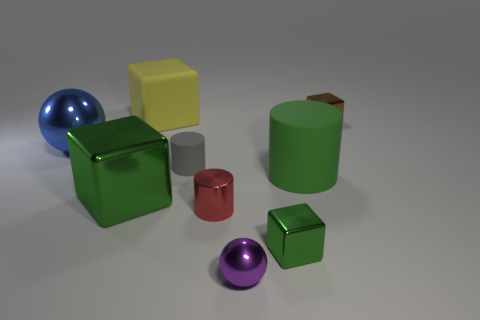Are there any large matte objects that have the same shape as the tiny gray object?
Ensure brevity in your answer.  Yes. What shape is the large matte thing that is behind the metal block that is right of the tiny green block?
Ensure brevity in your answer.  Cube. What number of cylinders are either large green metallic things or big matte objects?
Give a very brief answer. 1. There is a large object that is the same color as the large rubber cylinder; what is its material?
Offer a terse response. Metal. There is a large metal thing in front of the small gray cylinder; is its shape the same as the tiny metallic object on the left side of the purple thing?
Give a very brief answer. No. There is a cube that is both in front of the yellow matte thing and behind the large green matte cylinder; what is its color?
Offer a very short reply. Brown. Does the matte block have the same color as the large object that is right of the matte cube?
Ensure brevity in your answer.  No. What size is the block that is both in front of the blue metallic ball and on the left side of the tiny purple ball?
Your answer should be compact. Large. How many other objects are there of the same color as the large rubber cylinder?
Keep it short and to the point. 2. There is a metallic sphere that is in front of the green shiny cube left of the green metal object that is to the right of the tiny rubber cylinder; what is its size?
Make the answer very short. Small. 